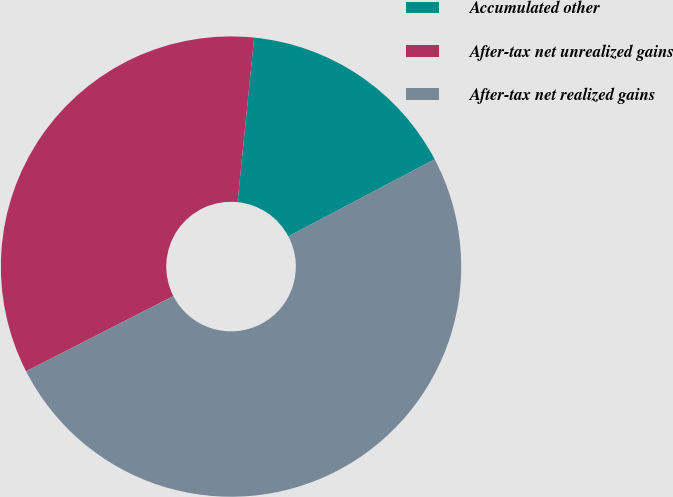<chart> <loc_0><loc_0><loc_500><loc_500><pie_chart><fcel>Accumulated other<fcel>After-tax net unrealized gains<fcel>After-tax net realized gains<nl><fcel>15.68%<fcel>34.12%<fcel>50.2%<nl></chart> 